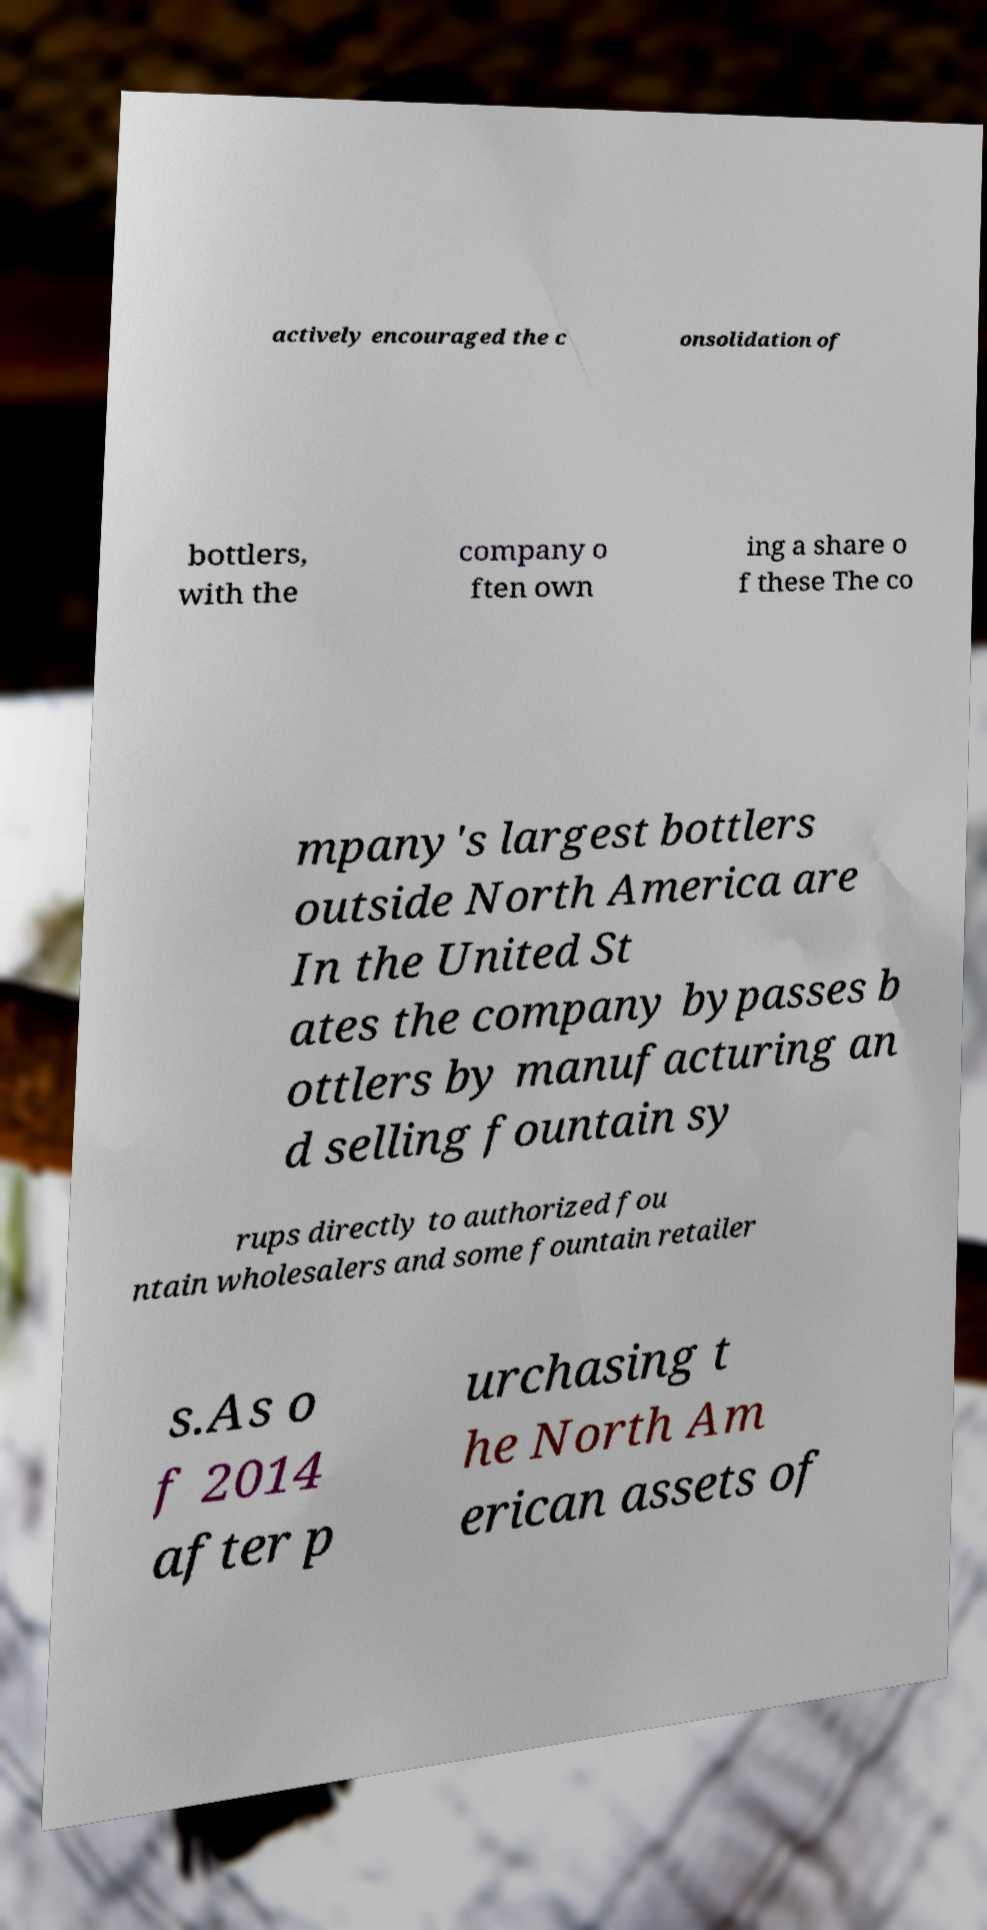I need the written content from this picture converted into text. Can you do that? actively encouraged the c onsolidation of bottlers, with the company o ften own ing a share o f these The co mpany's largest bottlers outside North America are In the United St ates the company bypasses b ottlers by manufacturing an d selling fountain sy rups directly to authorized fou ntain wholesalers and some fountain retailer s.As o f 2014 after p urchasing t he North Am erican assets of 